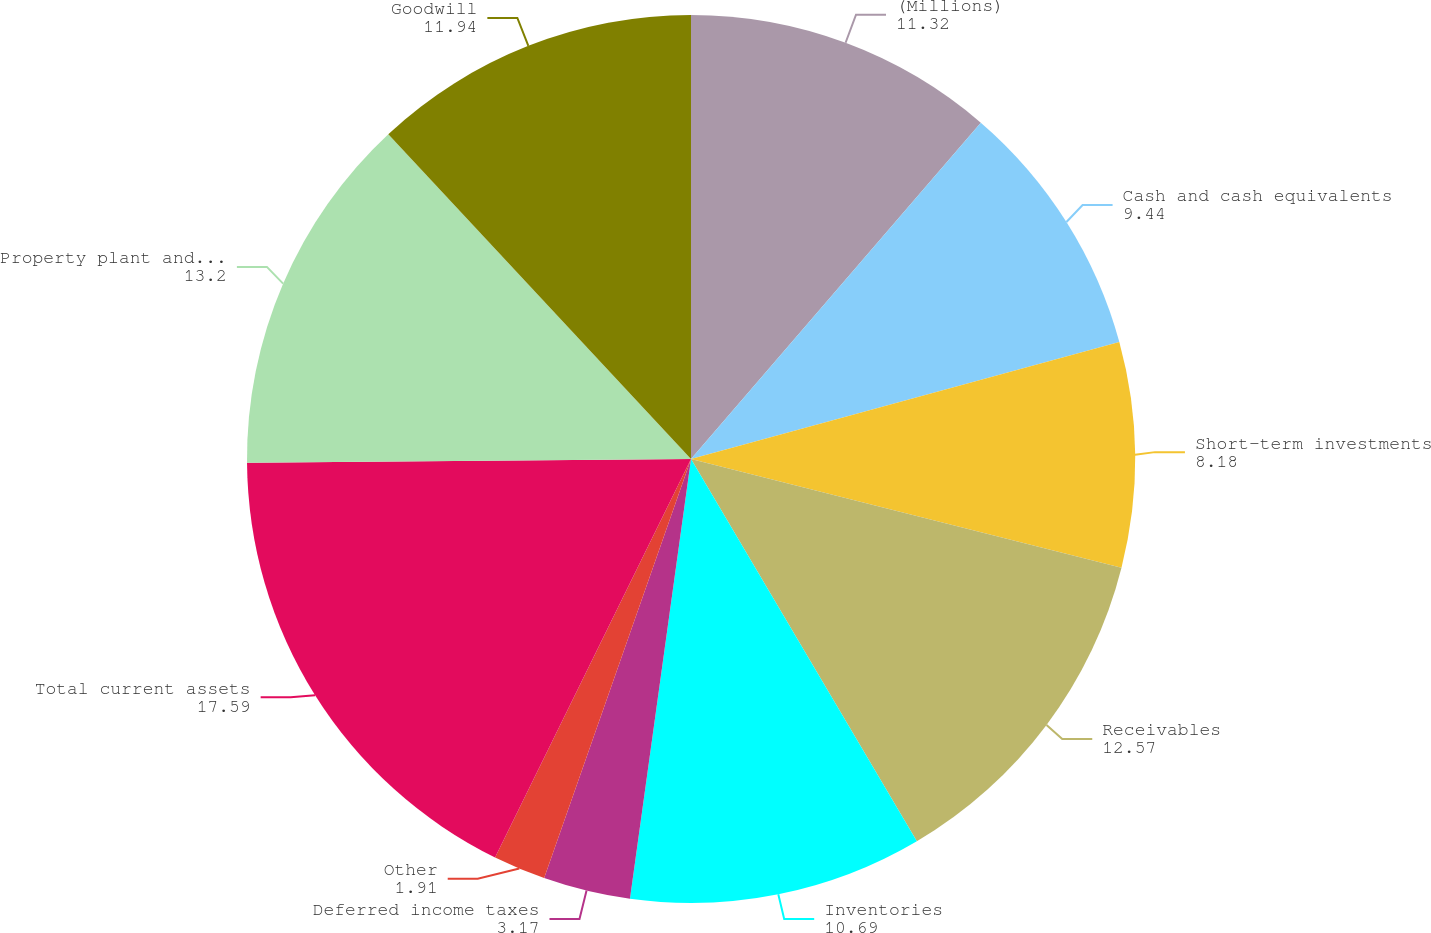<chart> <loc_0><loc_0><loc_500><loc_500><pie_chart><fcel>(Millions)<fcel>Cash and cash equivalents<fcel>Short-term investments<fcel>Receivables<fcel>Inventories<fcel>Deferred income taxes<fcel>Other<fcel>Total current assets<fcel>Property plant and equipment<fcel>Goodwill<nl><fcel>11.32%<fcel>9.44%<fcel>8.18%<fcel>12.57%<fcel>10.69%<fcel>3.17%<fcel>1.91%<fcel>17.59%<fcel>13.2%<fcel>11.94%<nl></chart> 